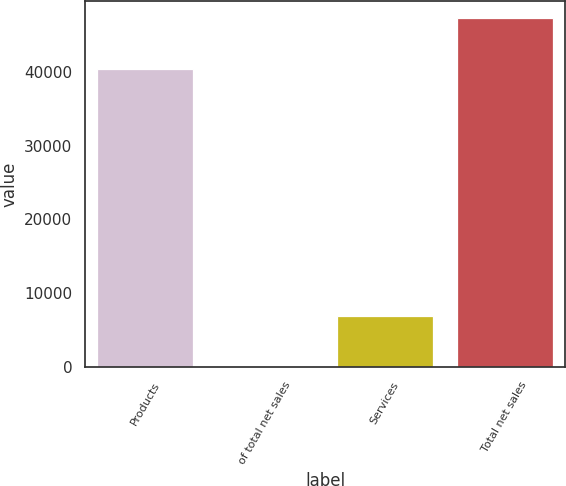Convert chart to OTSL. <chart><loc_0><loc_0><loc_500><loc_500><bar_chart><fcel>Products<fcel>of total net sales<fcel>Services<fcel>Total net sales<nl><fcel>40365<fcel>85.4<fcel>6883<fcel>47248<nl></chart> 